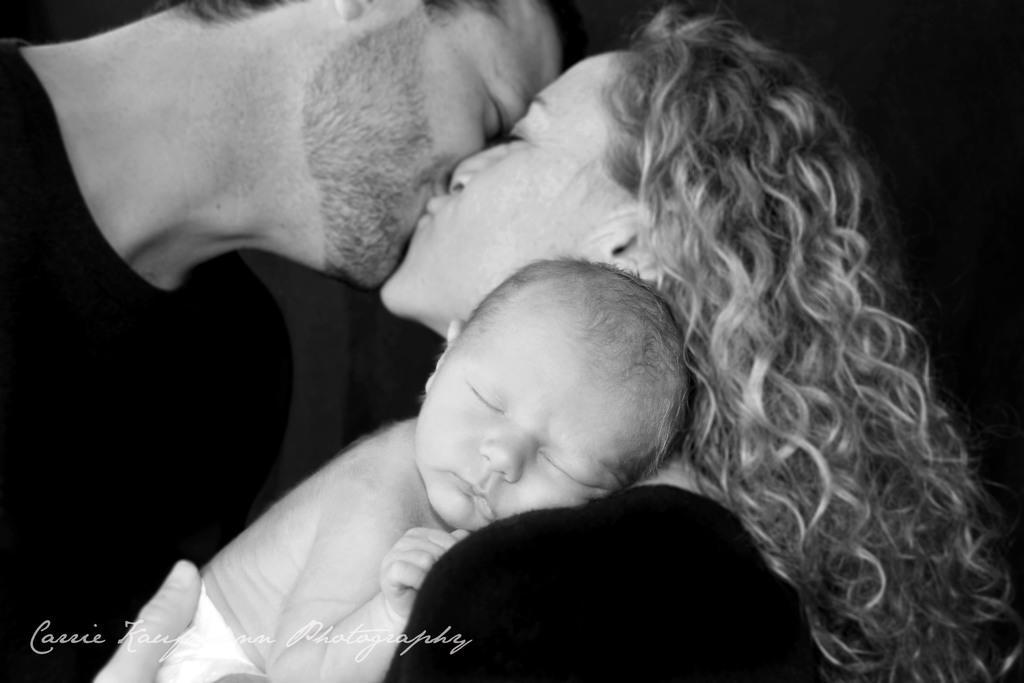How would you summarize this image in a sentence or two? This is black and white picture,there are two people kissing each other and this woman holding a baby. In the bottom left of the image we can see water mark. 